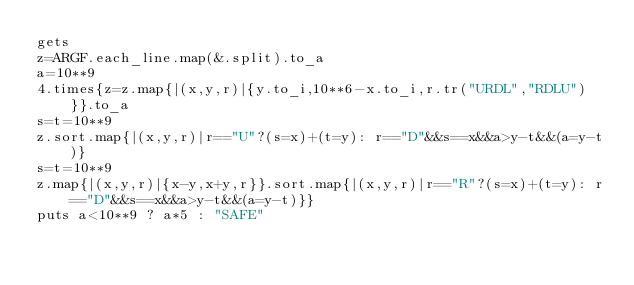<code> <loc_0><loc_0><loc_500><loc_500><_Crystal_>gets
z=ARGF.each_line.map(&.split).to_a
a=10**9
4.times{z=z.map{|(x,y,r)|{y.to_i,10**6-x.to_i,r.tr("URDL","RDLU")}}.to_a
s=t=10**9
z.sort.map{|(x,y,r)|r=="U"?(s=x)+(t=y): r=="D"&&s==x&&a>y-t&&(a=y-t)}
s=t=10**9
z.map{|(x,y,r)|{x-y,x+y,r}}.sort.map{|(x,y,r)|r=="R"?(s=x)+(t=y): r=="D"&&s==x&&a>y-t&&(a=y-t)}}
puts a<10**9 ? a*5 : "SAFE"</code> 